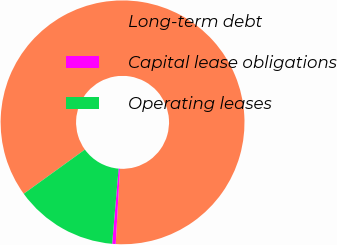<chart> <loc_0><loc_0><loc_500><loc_500><pie_chart><fcel>Long-term debt<fcel>Capital lease obligations<fcel>Operating leases<nl><fcel>85.86%<fcel>0.47%<fcel>13.68%<nl></chart> 